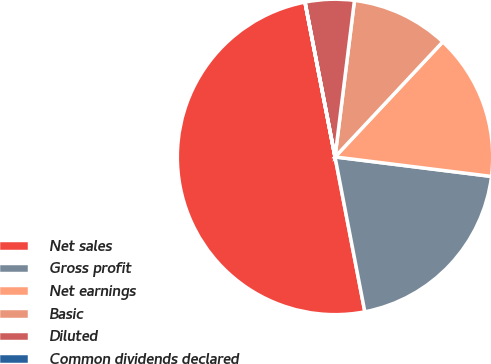Convert chart. <chart><loc_0><loc_0><loc_500><loc_500><pie_chart><fcel>Net sales<fcel>Gross profit<fcel>Net earnings<fcel>Basic<fcel>Diluted<fcel>Common dividends declared<nl><fcel>49.97%<fcel>20.0%<fcel>15.0%<fcel>10.01%<fcel>5.01%<fcel>0.01%<nl></chart> 